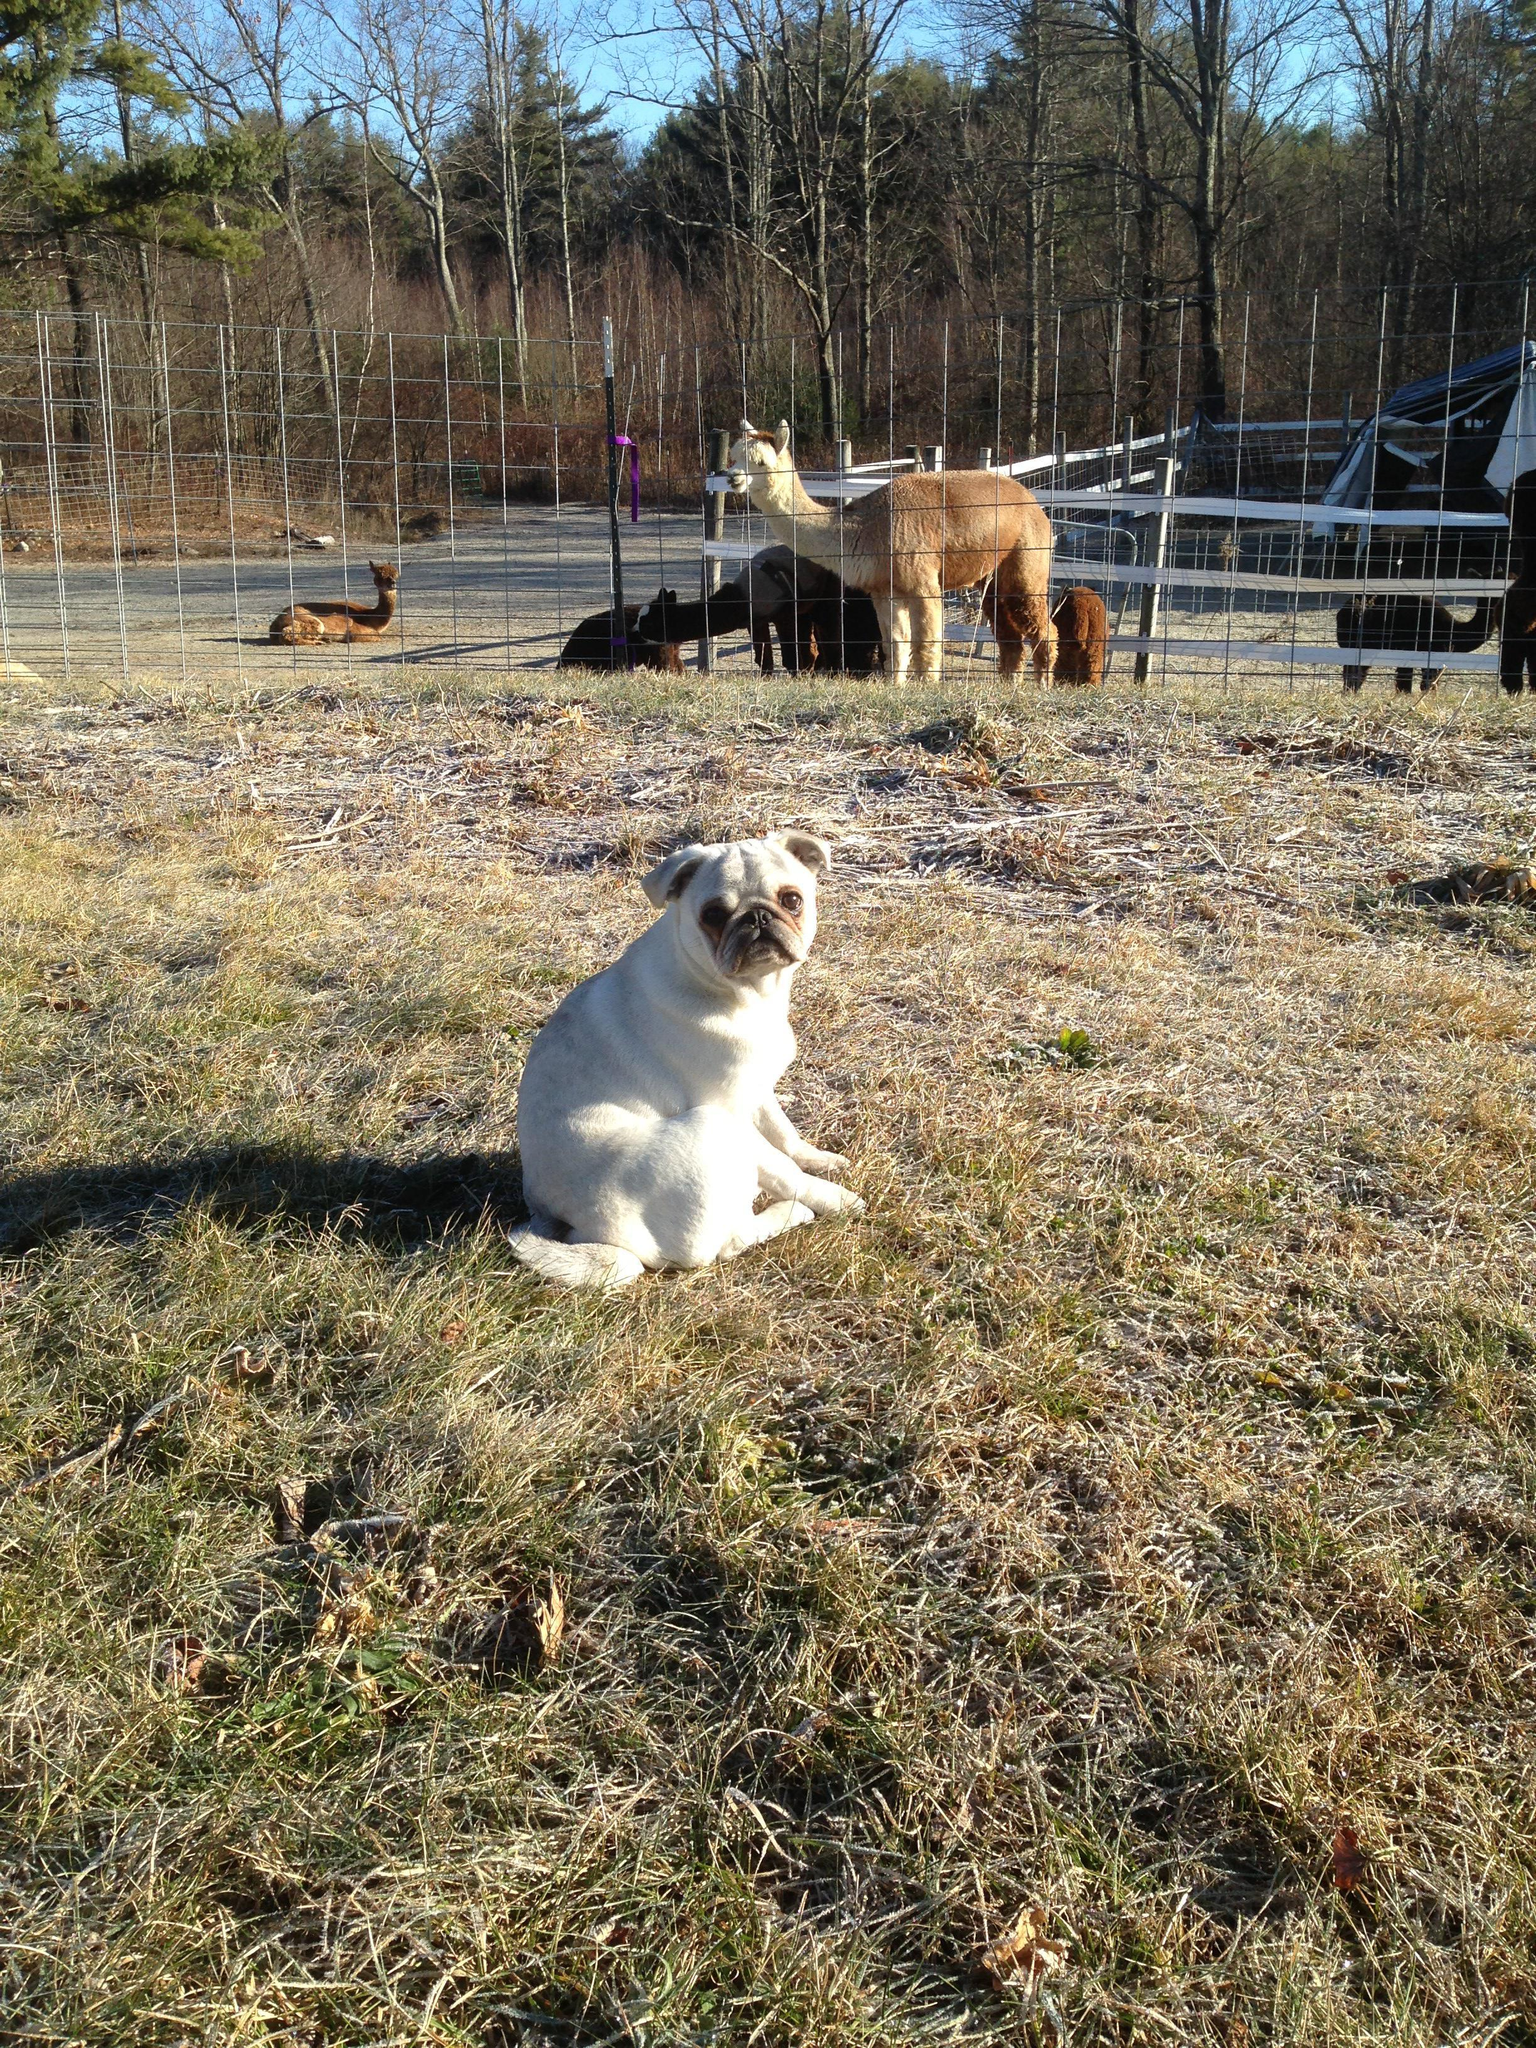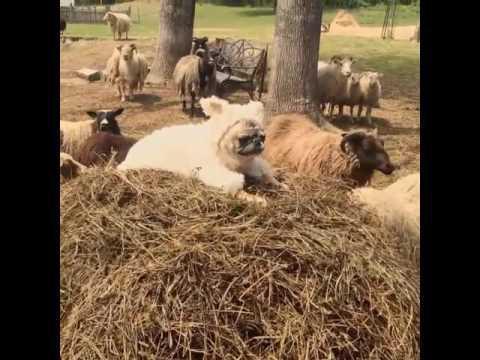The first image is the image on the left, the second image is the image on the right. For the images displayed, is the sentence "There is a person in the image on the right." factually correct? Answer yes or no. No. The first image is the image on the left, the second image is the image on the right. Evaluate the accuracy of this statement regarding the images: "In one image, a woman is shown with many little dogs.". Is it true? Answer yes or no. No. 